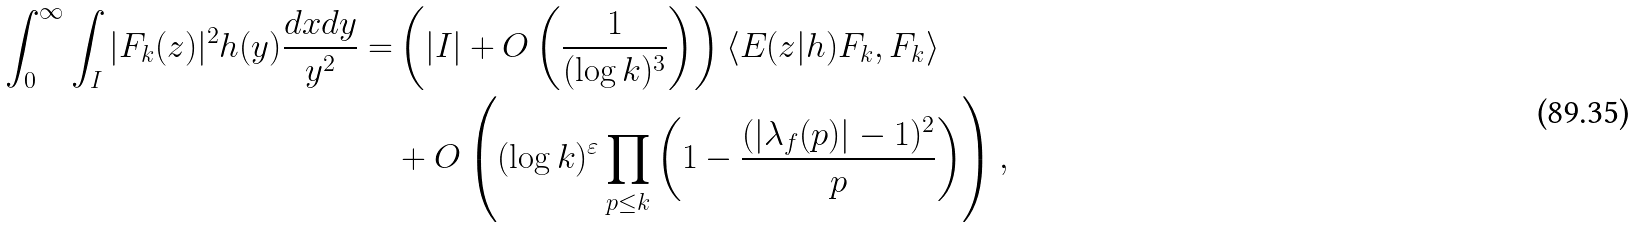Convert formula to latex. <formula><loc_0><loc_0><loc_500><loc_500>\int _ { 0 } ^ { \infty } \int _ { I } | F _ { k } ( z ) | ^ { 2 } h ( y ) \frac { d x d y } { y ^ { 2 } } = & \left ( | I | + O \left ( \frac { 1 } { ( \log k ) ^ { 3 } } \right ) \right ) \langle E ( z | h ) F _ { k } , F _ { k } \rangle \\ & + O \left ( ( \log k ) ^ { \varepsilon } \prod _ { p \leq k } \left ( 1 - \frac { ( | \lambda _ { f } ( p ) | - 1 ) ^ { 2 } } { p } \right ) \right ) ,</formula> 